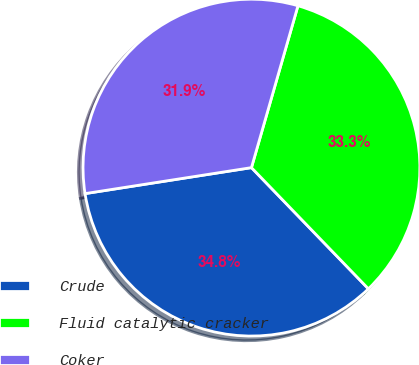Convert chart. <chart><loc_0><loc_0><loc_500><loc_500><pie_chart><fcel>Crude<fcel>Fluid catalytic cracker<fcel>Coker<nl><fcel>34.75%<fcel>33.33%<fcel>31.92%<nl></chart> 